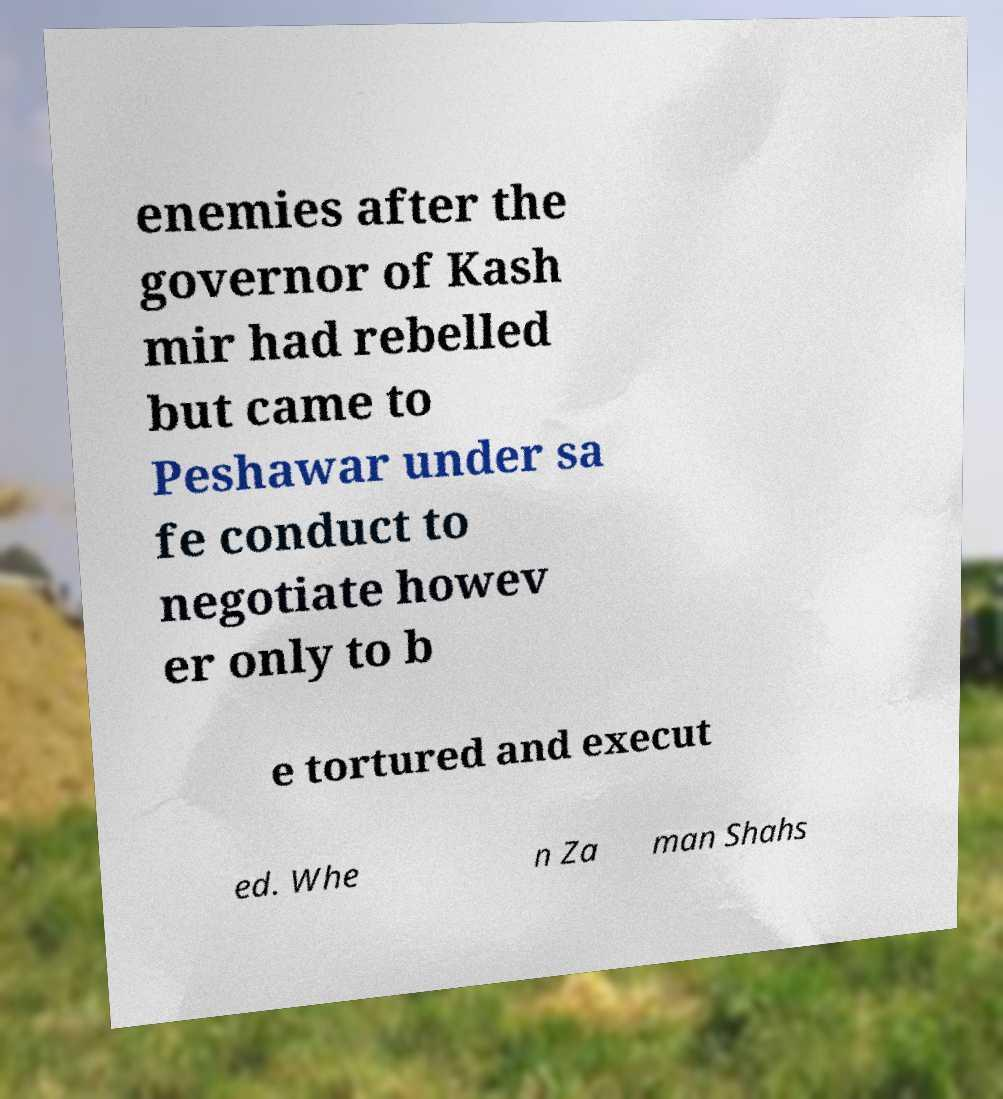Please read and relay the text visible in this image. What does it say? enemies after the governor of Kash mir had rebelled but came to Peshawar under sa fe conduct to negotiate howev er only to b e tortured and execut ed. Whe n Za man Shahs 